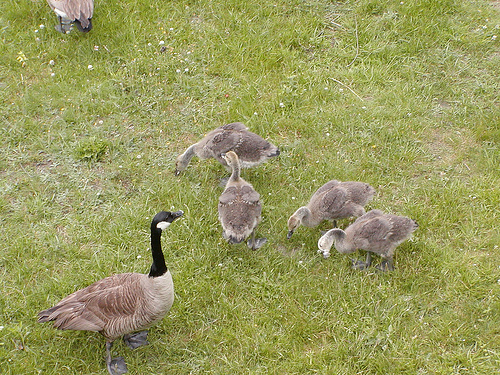<image>
Is there a goose above the gander? No. The goose is not positioned above the gander. The vertical arrangement shows a different relationship. 